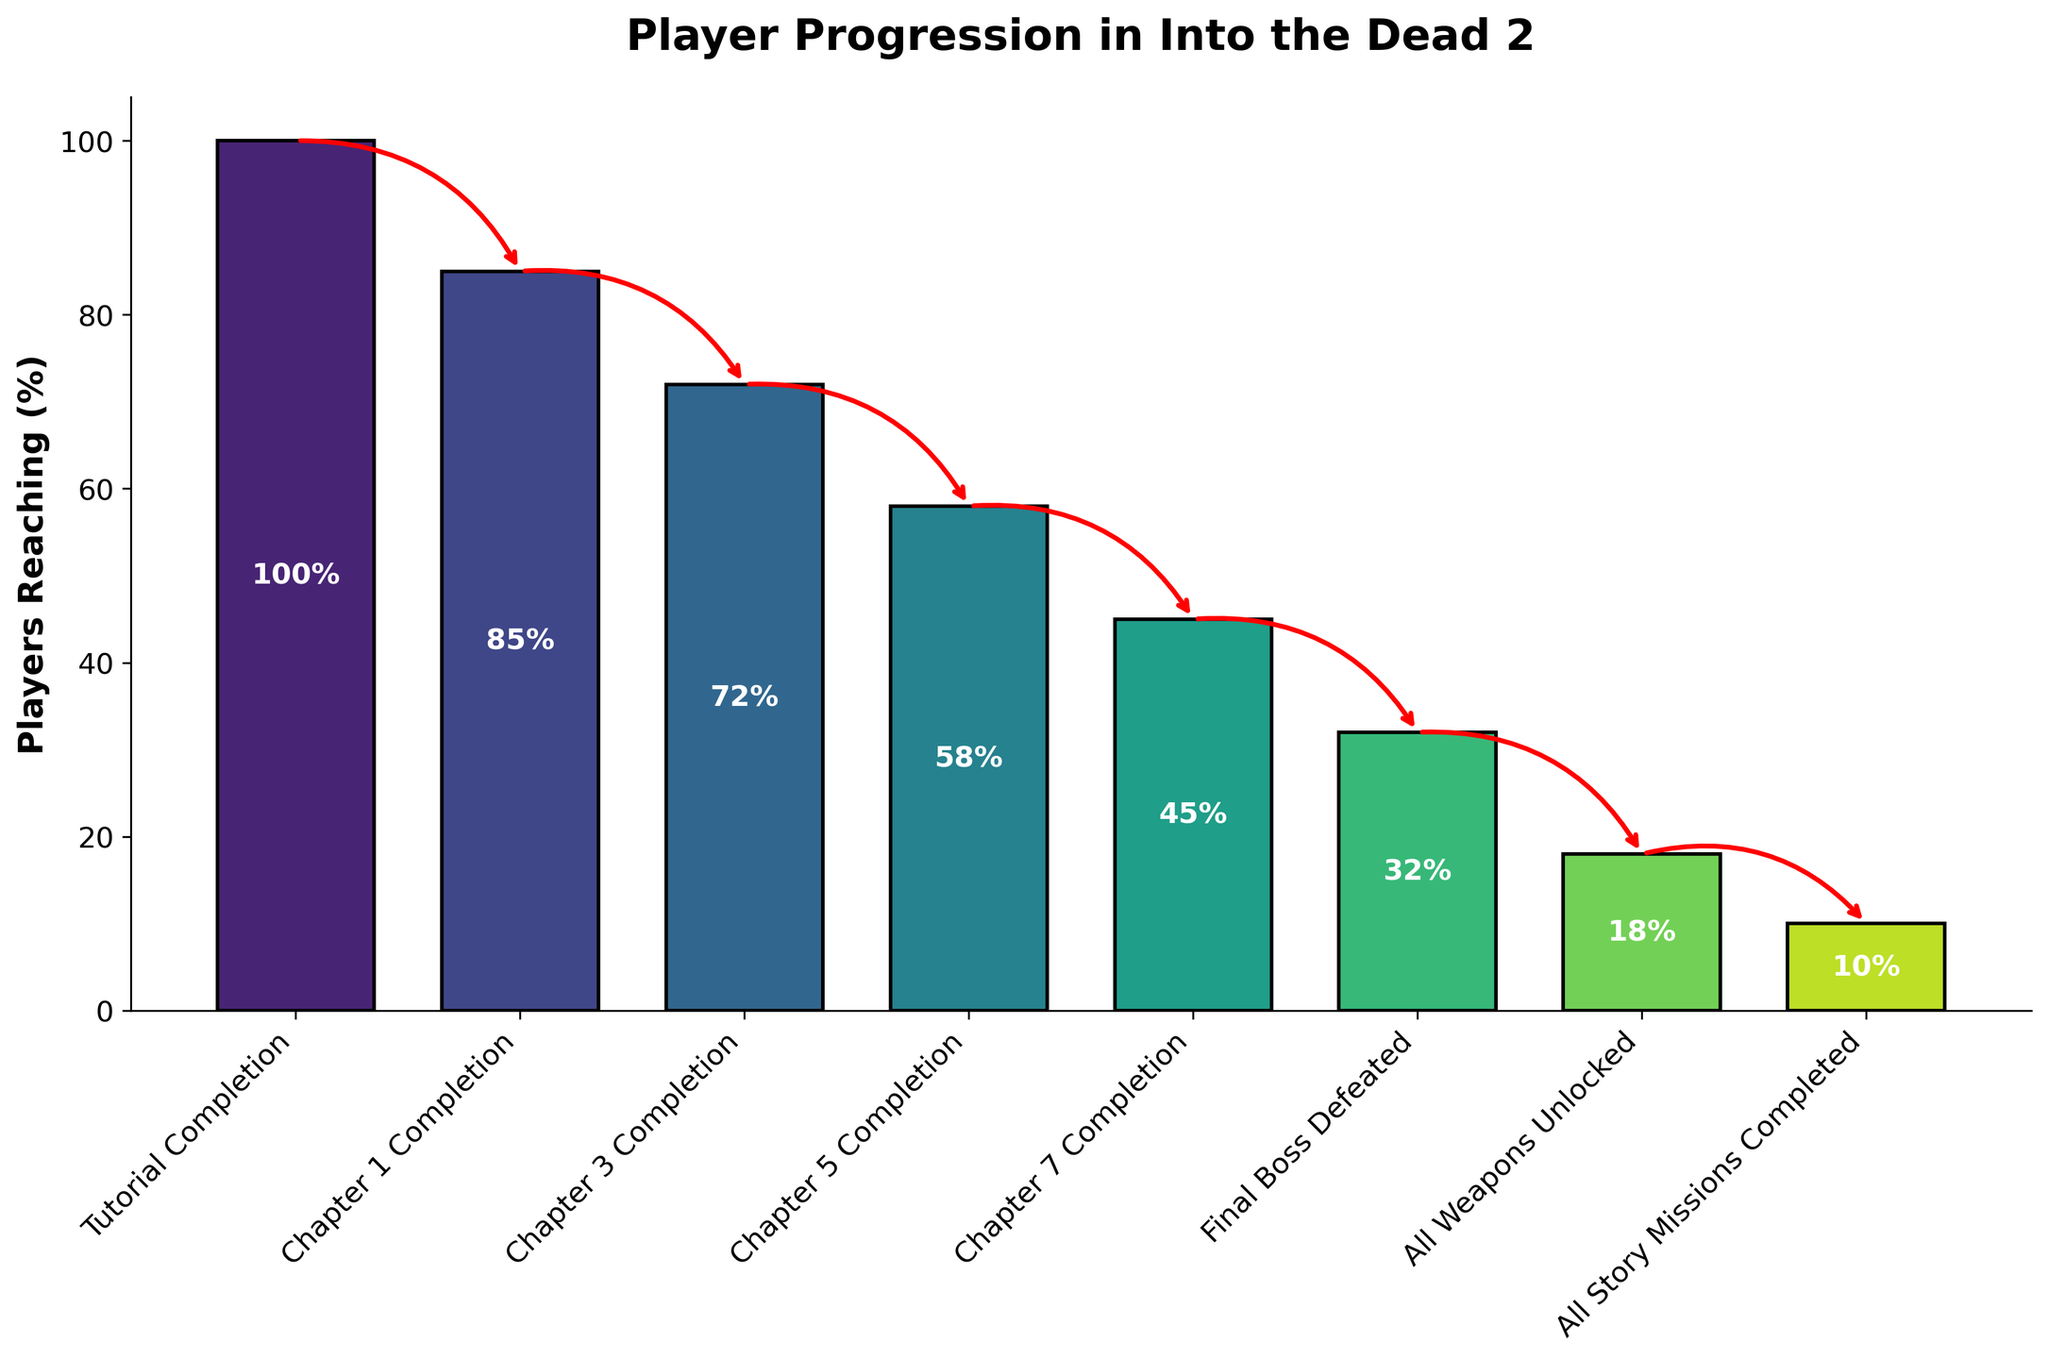How many milestones are included in the funnel chart? Count the number of levels listed along the x-axis in the funnel chart.
Answer: 8 What percentage of players have completed Chapter 5? Look at the data point marked "Chapter 5 Completion" on the funnel chart and read the percentage value.
Answer: 58% What is the percentage point difference between players who completed the tutorial and those who unlocked all weapons? Subtract the percentage of players who unlocked all weapons from the percentage of players who completed the tutorial. Calculation: 100% - 18% = 82%
Answer: 82% Which milestone has the lowest percentage of players reaching it? Identify the milestone on the funnel chart with the smallest bar, which represents the lowest percentage.
Answer: All Story Missions Completed By how many percentage points do players drop off between Chapter 7 Completion and Final Boss Defeated? Subtract the percentage of players who defeated the Final Boss from those who completed Chapter 7. Calculation: 45% - 32% = 13%
Answer: 13% Which milestone do exactly 45% of players reach? Locate the milestone on the funnel chart where the bar represents 45% and read its label.
Answer: Chapter 7 Completion What is the total percentage of players who did not proceed beyond Chapter 3 Completion? Subtract the percentage of players who completed Chapter 3 from the percentage who completed the tutorial. Calculation: 100% - 72% = 28%
Answer: 28% How does the number of players completing Chapter 1 compare to those completing Chapter 5? Compare the percentages of players completing Chapter 1 and Chapter 5 by reading their respective bars on the chart.
Answer: Chapter 1 has a higher percentage Between which two consecutive milestones is the biggest drop in player percentage observed? Identify the pair of consecutive milestones where the bar heights show the greatest difference in percentage.
Answer: Chapter 1 Completion and Chapter 3 Completion What percentage of players remain to unlock all weapons after defeating the final boss? Subtract the percentage of players who unlocked all weapons from those who defeated the final boss. Calculation: 32% - 18% = 14%
Answer: 14% 